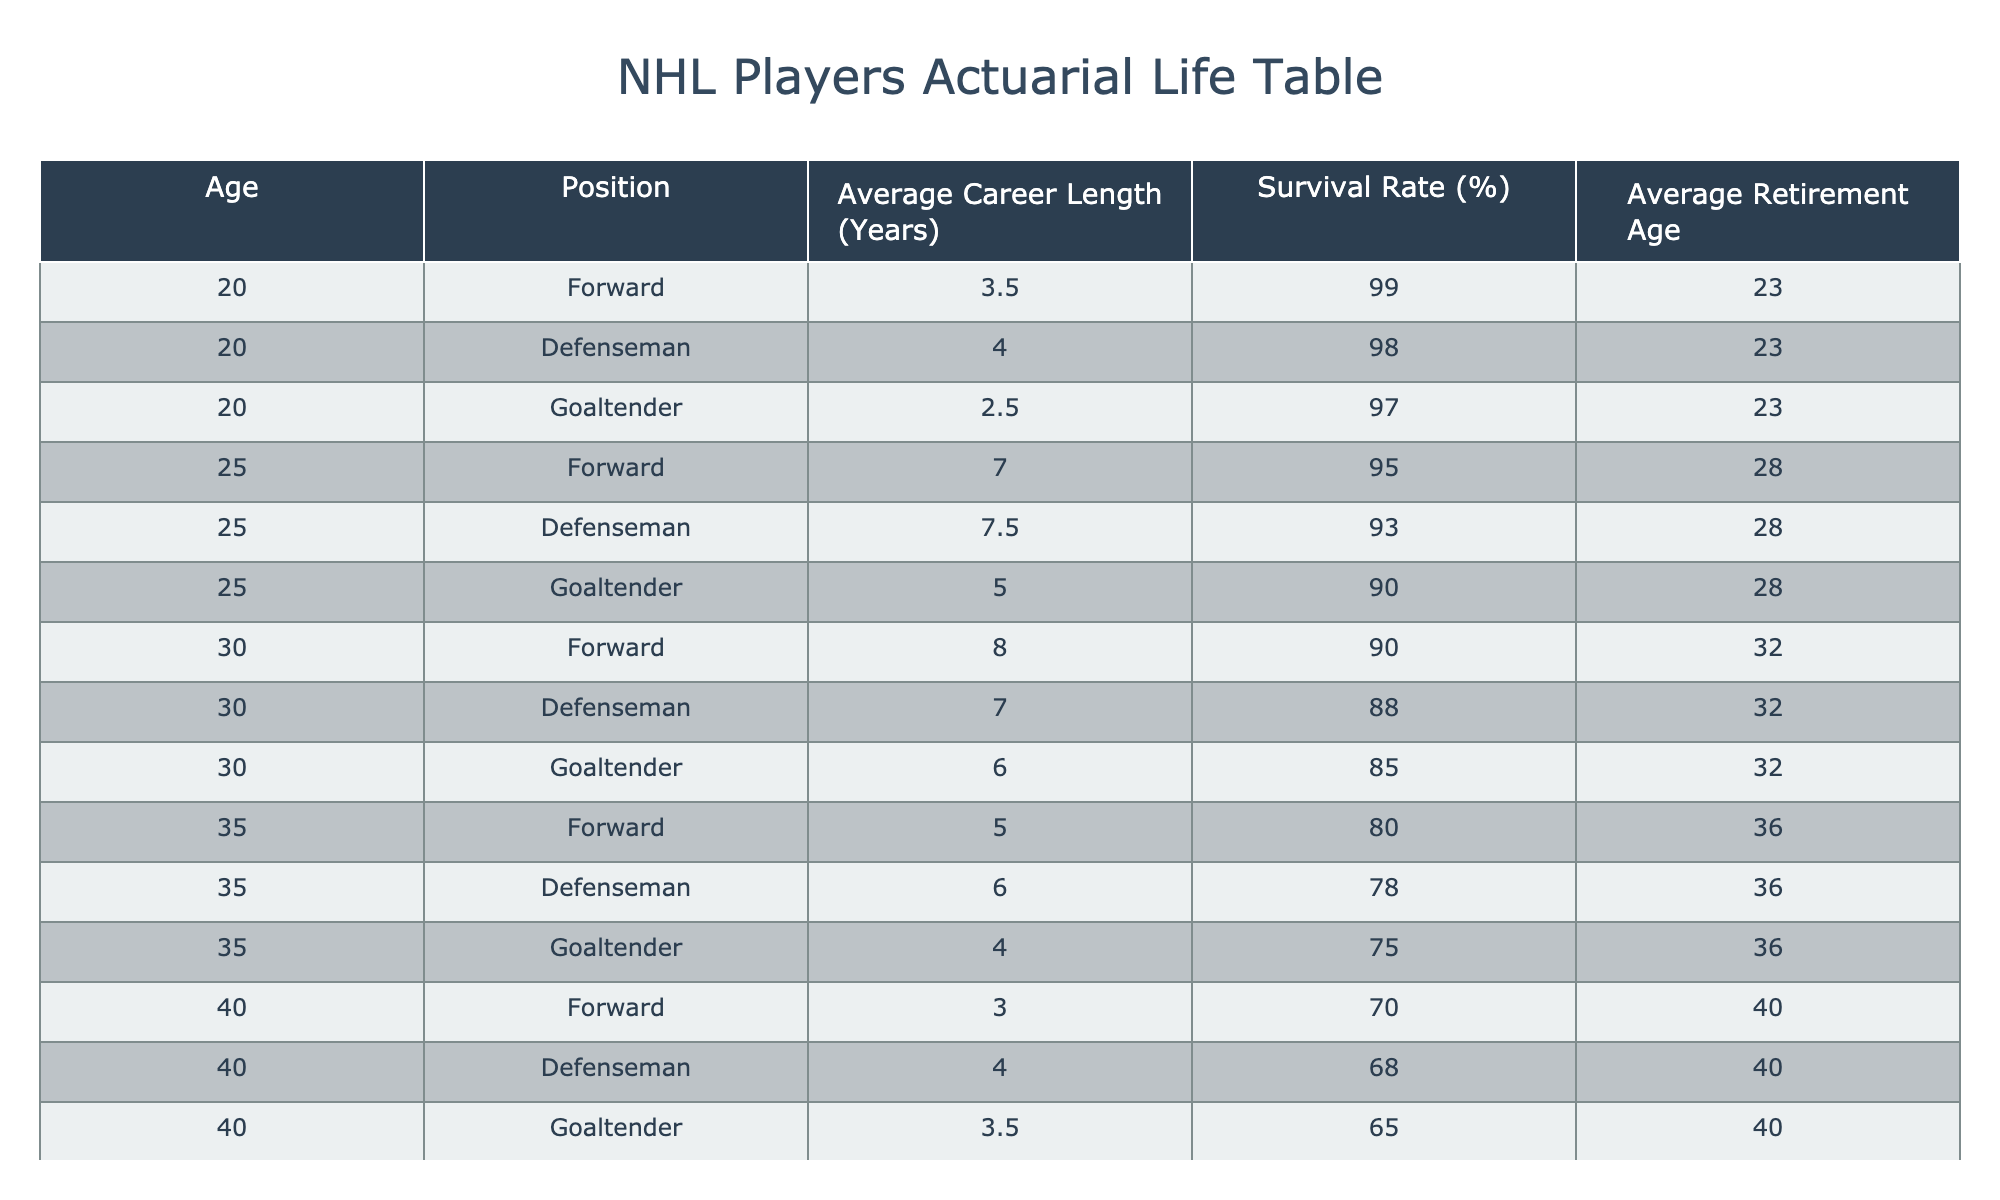What is the average career length of a Forward? In the table, the average career length of a Forward is given in the "Average Career Length (Years)" column where the position is Forward. We see values of 3.5, 7.0, 8.0, 5.0, 3.0, and 1.5 for ages 20, 25, 30, 35, 40, and 45 respectively. To find the average, we sum these values (3.5 + 7.0 + 8.0 + 5.0 + 3.0 + 1.5) which equals 28.0 years, and divide by the number of data points (6), resulting in an average of 28.0/6 = 4.67 years.
Answer: 4.67 What is the survival rate for a Goaltender aged 40? Looking at the table, we find the entry for a Goaltender at age 40. The corresponding survival rate is provided directly in the "Survival Rate (%)" column, which shows a survival rate of 65% for that age and position.
Answer: 65% How does the average retirement age for Defensemen compare to that of Forwards? From the table, we see the average retirement age for Defensemen is 40 and for Forwards, it is also 40. Thus, they have the same retirement age.
Answer: They are the same Are Goaltenders more likely to have longer or shorter average career lengths compared to Forwards at age 30? At age 30, the average career length for a Goaltender is 6.0 years, while for a Forward, it is 8.0 years. Since 6.0 is less than 8.0, Goaltenders have shorter average career lengths compared to Forwards at this age.
Answer: Goaltenders have shorter career lengths What is the average career length of NHL players at age 25? Looking at the table, the average career lengths at age 25 are 7.0 for Forwards, 7.5 for Defensemen, and 5.0 for Goaltenders. To find the overall average, we sum these values (7.0 + 7.5 + 5.0) which equals 19.5 and divide by the three positions. Hence, the average is 19.5/3 = 6.5 years.
Answer: 6.5 Is it true that all positions have the same survival rate at age 40? For age 40, we have the survival rates: 70% for Forwards, 68% for Defensemen, and 65% for Goaltenders. Since these values differ, it is false that all positions have the same survival rate at this age.
Answer: No Which position has the highest survival rate at age 35? For age 35, the survival rates for the three positions are: 80% for Forwards, 78% for Defensemen, and 75% for Goaltenders. Among these, Forwards have the highest survival rate at this age.
Answer: Forwards What is the decrease in survival rate for Defensemen from age 25 to age 35? At age 25, the survival rate for Defensemen is 93%, and at age 35, it is 78%. To find the decrease, we subtract 78 from 93, which gives us a decrease of 15 percentage points in survival rate.
Answer: 15 percentage points 